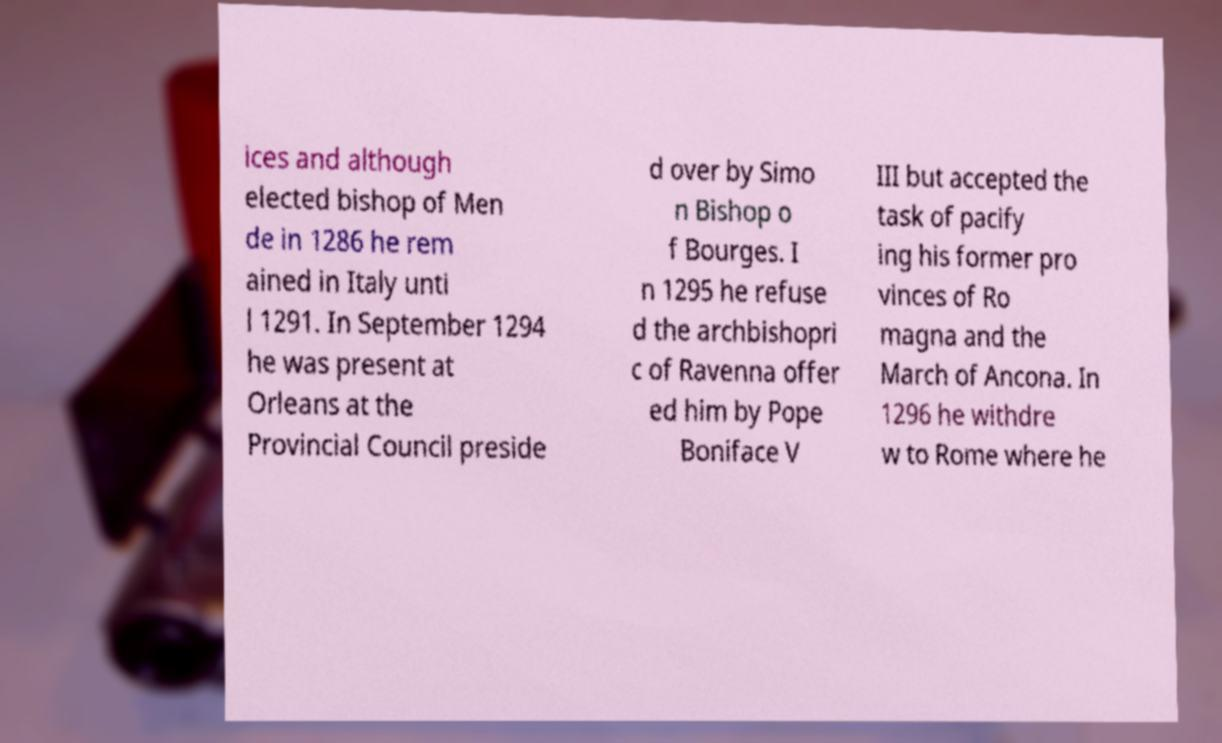I need the written content from this picture converted into text. Can you do that? ices and although elected bishop of Men de in 1286 he rem ained in Italy unti l 1291. In September 1294 he was present at Orleans at the Provincial Council preside d over by Simo n Bishop o f Bourges. I n 1295 he refuse d the archbishopri c of Ravenna offer ed him by Pope Boniface V III but accepted the task of pacify ing his former pro vinces of Ro magna and the March of Ancona. In 1296 he withdre w to Rome where he 